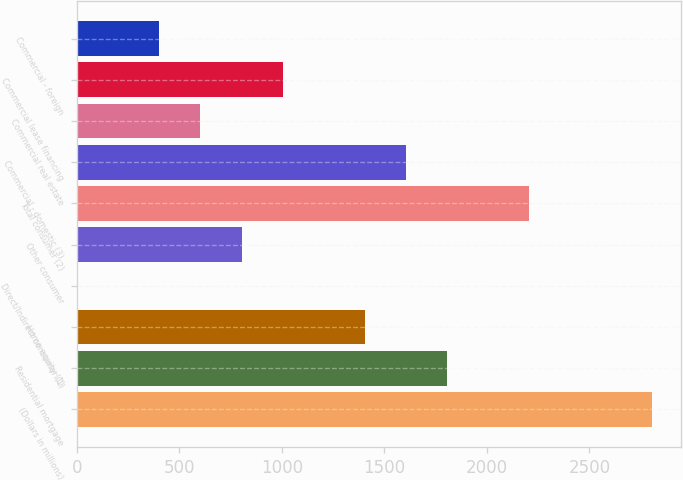Convert chart. <chart><loc_0><loc_0><loc_500><loc_500><bar_chart><fcel>(Dollars in millions)<fcel>Residential mortgage<fcel>Home equity (1)<fcel>Direct/Indirect consumer (1)<fcel>Other consumer<fcel>Total consumer (2)<fcel>Commercial - domestic (3)<fcel>Commercial real estate<fcel>Commercial lease financing<fcel>Commercial - foreign<nl><fcel>2805.8<fcel>1804.8<fcel>1404.4<fcel>3<fcel>803.8<fcel>2205.2<fcel>1604.6<fcel>603.6<fcel>1004<fcel>403.4<nl></chart> 